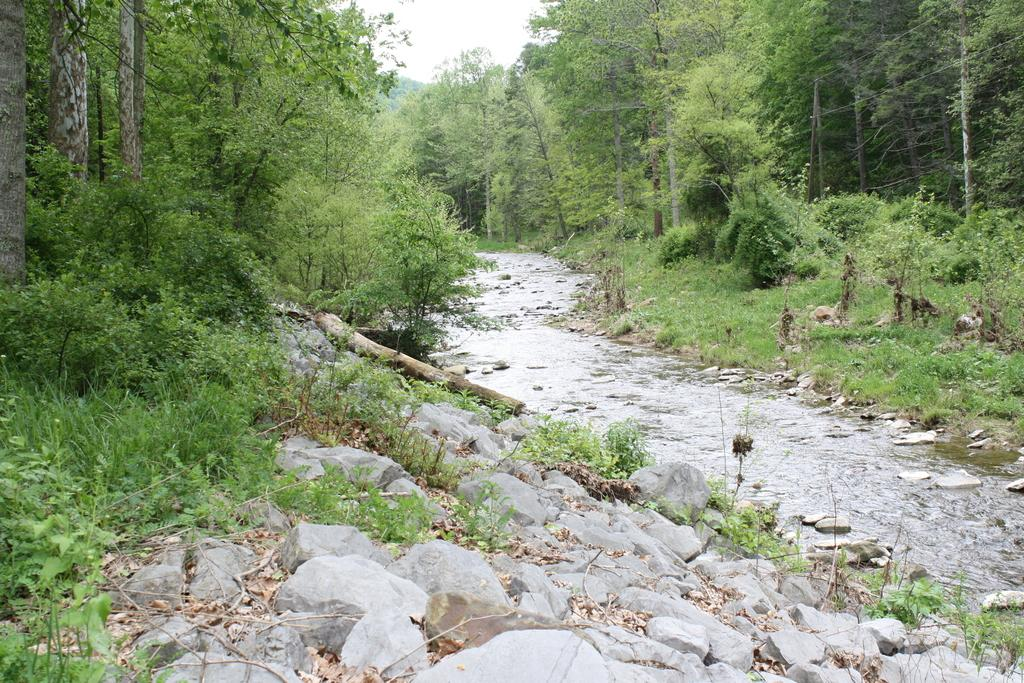What is located at the bottom of the image? There are stones and water at the bottom of the image. What type of vegetation is present in the middle of the image? There are trees and grass in the middle of the image. What is visible at the top of the image? The sky is visible at the top of the image. What type of tooth can be seen in the image? There is no tooth present in the image. What meal is being prepared in the image? There is no meal preparation visible in the image. 